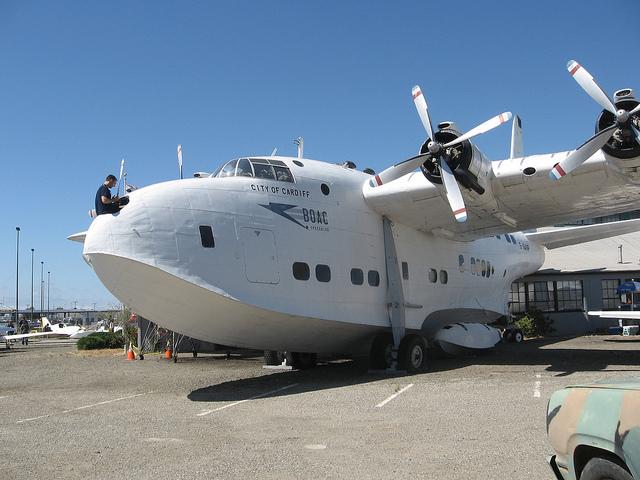What kind of plane is this?
Keep it brief. Cargo. Is the plane flying?
Short answer required. No. Why is a man on the nose of the plane?
Short answer required. Mechanic. 